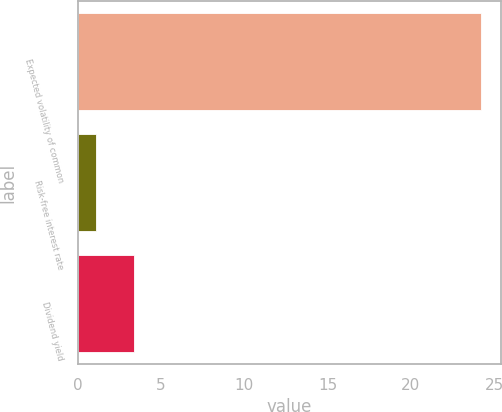Convert chart to OTSL. <chart><loc_0><loc_0><loc_500><loc_500><bar_chart><fcel>Expected volatility of common<fcel>Risk-free interest rate<fcel>Dividend yield<nl><fcel>24.2<fcel>1.1<fcel>3.41<nl></chart> 